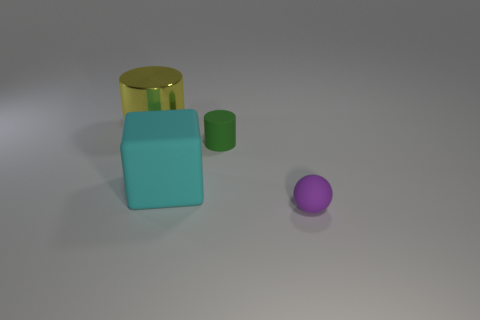Is the number of tiny green cubes greater than the number of matte blocks? The number of tiny green cubes is not greater than the number of matte blocks, as there appears to be only one tiny green cube and several objects that may be considered 'matte blocks', depending on the criteria for matte finish. 